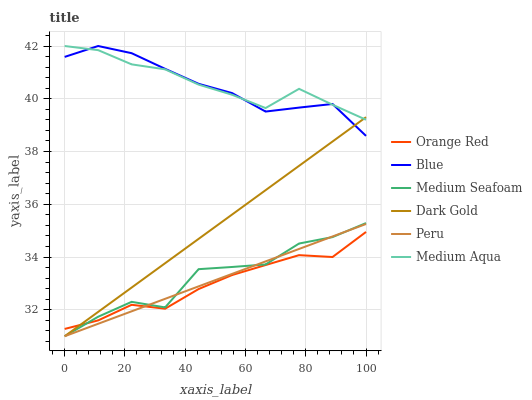Does Orange Red have the minimum area under the curve?
Answer yes or no. Yes. Does Medium Aqua have the maximum area under the curve?
Answer yes or no. Yes. Does Dark Gold have the minimum area under the curve?
Answer yes or no. No. Does Dark Gold have the maximum area under the curve?
Answer yes or no. No. Is Peru the smoothest?
Answer yes or no. Yes. Is Medium Seafoam the roughest?
Answer yes or no. Yes. Is Dark Gold the smoothest?
Answer yes or no. No. Is Dark Gold the roughest?
Answer yes or no. No. Does Dark Gold have the lowest value?
Answer yes or no. Yes. Does Medium Aqua have the lowest value?
Answer yes or no. No. Does Medium Aqua have the highest value?
Answer yes or no. Yes. Does Dark Gold have the highest value?
Answer yes or no. No. Is Medium Seafoam less than Blue?
Answer yes or no. Yes. Is Medium Aqua greater than Orange Red?
Answer yes or no. Yes. Does Blue intersect Dark Gold?
Answer yes or no. Yes. Is Blue less than Dark Gold?
Answer yes or no. No. Is Blue greater than Dark Gold?
Answer yes or no. No. Does Medium Seafoam intersect Blue?
Answer yes or no. No. 